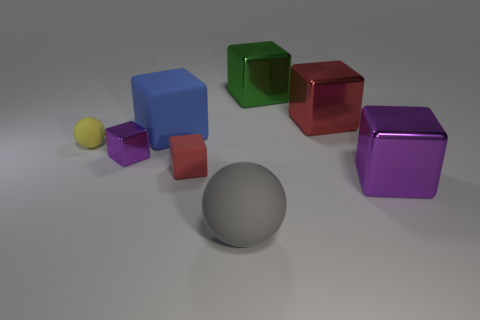The rubber cube that is in front of the yellow matte thing is what color?
Keep it short and to the point. Red. What number of other objects are the same color as the tiny shiny thing?
Your response must be concise. 1. Is there anything else that has the same size as the yellow rubber sphere?
Offer a terse response. Yes. Does the purple metal cube behind the red rubber block have the same size as the small yellow ball?
Provide a succinct answer. Yes. There is a sphere in front of the red rubber block; what is its material?
Ensure brevity in your answer.  Rubber. Is there any other thing that is the same shape as the big gray rubber object?
Offer a terse response. Yes. What number of matte objects are green things or big purple cubes?
Your answer should be compact. 0. Are there fewer matte objects that are left of the tiny red rubber block than small red matte things?
Make the answer very short. No. There is a thing right of the red object behind the tiny matte thing left of the tiny rubber block; what is its shape?
Offer a very short reply. Cube. Does the small metal object have the same color as the tiny sphere?
Your answer should be very brief. No. 